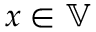<formula> <loc_0><loc_0><loc_500><loc_500>x \in \mathbb { V }</formula> 